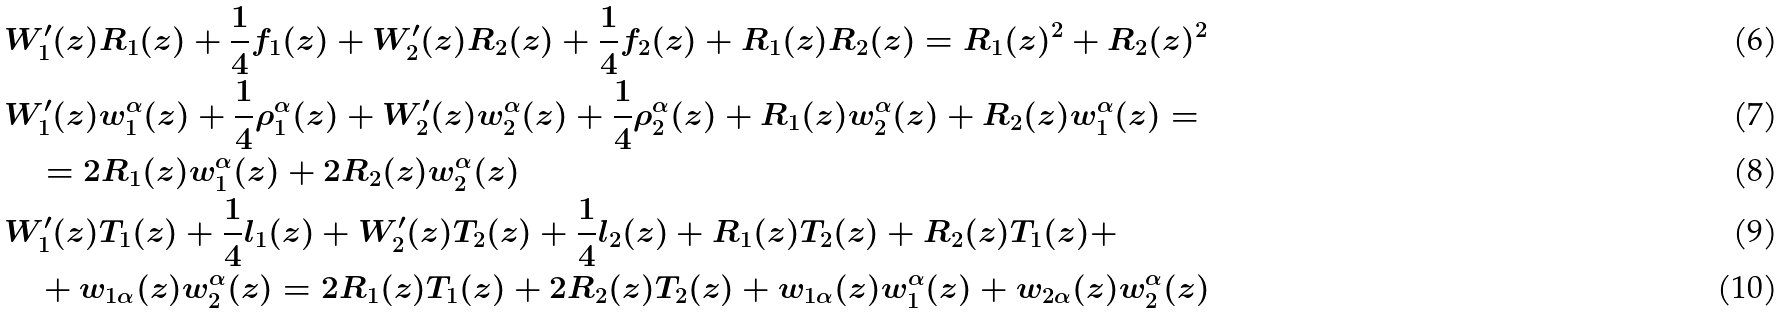Convert formula to latex. <formula><loc_0><loc_0><loc_500><loc_500>& W _ { 1 } ^ { \prime } ( z ) R _ { 1 } ( z ) + \frac { 1 } { 4 } f _ { 1 } ( z ) + W _ { 2 } ^ { \prime } ( z ) R _ { 2 } ( z ) + \frac { 1 } { 4 } f _ { 2 } ( z ) + R _ { 1 } ( z ) R _ { 2 } ( z ) = R _ { 1 } ( z ) ^ { 2 } + R _ { 2 } ( z ) ^ { 2 } \\ & W _ { 1 } ^ { \prime } ( z ) w _ { 1 } ^ { \alpha } ( z ) + \frac { 1 } { 4 } \rho _ { 1 } ^ { \alpha } ( z ) + W _ { 2 } ^ { \prime } ( z ) w _ { 2 } ^ { \alpha } ( z ) + \frac { 1 } { 4 } \rho _ { 2 } ^ { \alpha } ( z ) + R _ { 1 } ( z ) w _ { 2 } ^ { \alpha } ( z ) + R _ { 2 } ( z ) w _ { 1 } ^ { \alpha } ( z ) = \\ & \quad = 2 R _ { 1 } ( z ) w _ { 1 } ^ { \alpha } ( z ) + 2 R _ { 2 } ( z ) w _ { 2 } ^ { \alpha } ( z ) \\ & W _ { 1 } ^ { \prime } ( z ) T _ { 1 } ( z ) + \frac { 1 } { 4 } l _ { 1 } ( z ) + W _ { 2 } ^ { \prime } ( z ) T _ { 2 } ( z ) + \frac { 1 } { 4 } l _ { 2 } ( z ) + R _ { 1 } ( z ) T _ { 2 } ( z ) + R _ { 2 } ( z ) T _ { 1 } ( z ) + \\ & \quad + w _ { 1 \alpha } ( z ) w _ { 2 } ^ { \alpha } ( z ) = 2 R _ { 1 } ( z ) T _ { 1 } ( z ) + 2 R _ { 2 } ( z ) T _ { 2 } ( z ) + w _ { 1 \alpha } ( z ) w _ { 1 } ^ { \alpha } ( z ) + w _ { 2 \alpha } ( z ) w _ { 2 } ^ { \alpha } ( z )</formula> 